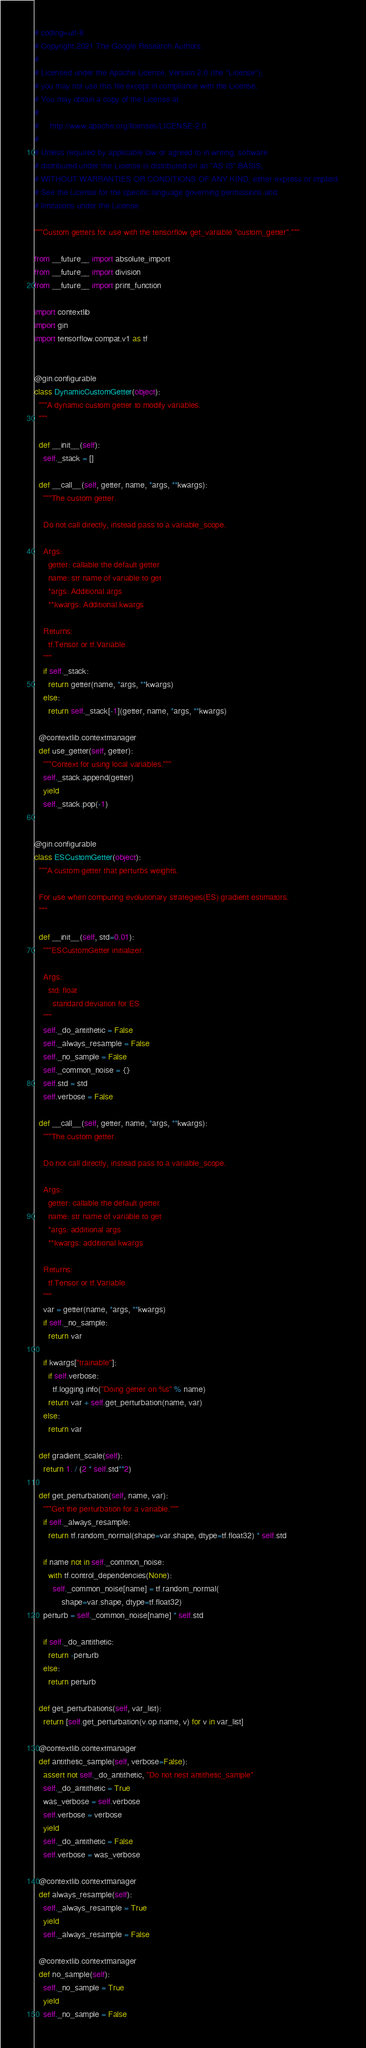<code> <loc_0><loc_0><loc_500><loc_500><_Python_># coding=utf-8
# Copyright 2021 The Google Research Authors.
#
# Licensed under the Apache License, Version 2.0 (the "License");
# you may not use this file except in compliance with the License.
# You may obtain a copy of the License at
#
#     http://www.apache.org/licenses/LICENSE-2.0
#
# Unless required by applicable law or agreed to in writing, software
# distributed under the License is distributed on an "AS IS" BASIS,
# WITHOUT WARRANTIES OR CONDITIONS OF ANY KIND, either express or implied.
# See the License for the specific language governing permissions and
# limitations under the License.

"""Custom getters for use with the tensorflow get_variable "custom_getter"."""

from __future__ import absolute_import
from __future__ import division
from __future__ import print_function

import contextlib
import gin
import tensorflow.compat.v1 as tf


@gin.configurable
class DynamicCustomGetter(object):
  """A dynamic custom getter to modify variables.
  """

  def __init__(self):
    self._stack = []

  def __call__(self, getter, name, *args, **kwargs):
    """The custom getter.

    Do not call directly, instead pass to a variable_scope.

    Args:
      getter: callable the default getter
      name: str name of variable to get
      *args: Additional args
      **kwargs: Additional kwargs

    Returns:
      tf.Tensor or tf.Variable
    """
    if self._stack:
      return getter(name, *args, **kwargs)
    else:
      return self._stack[-1](getter, name, *args, **kwargs)

  @contextlib.contextmanager
  def use_getter(self, getter):
    """Context for using local variables."""
    self._stack.append(getter)
    yield
    self._stack.pop(-1)


@gin.configurable
class ESCustomGetter(object):
  """A custom getter that perturbs weights.

  For use when computing evolutionary strategies(ES) gradient estimators.
  """

  def __init__(self, std=0.01):
    """ESCustomGetter initializer.

    Args:
      std: float
        standard deviation for ES
    """
    self._do_antithetic = False
    self._always_resample = False
    self._no_sample = False
    self._common_noise = {}
    self.std = std
    self.verbose = False

  def __call__(self, getter, name, *args, **kwargs):
    """The custom getter.

    Do not call directly, instead pass to a variable_scope.

    Args:
      getter: callable the default getter
      name: str name of variable to get
      *args: additional args
      **kwargs: additional kwargs

    Returns:
      tf.Tensor or tf.Variable
    """
    var = getter(name, *args, **kwargs)
    if self._no_sample:
      return var

    if kwargs["trainable"]:
      if self.verbose:
        tf.logging.info("Doing getter on %s" % name)
      return var + self.get_perturbation(name, var)
    else:
      return var

  def gradient_scale(self):
    return 1. / (2 * self.std**2)

  def get_perturbation(self, name, var):
    """Get the perturbation for a variable."""
    if self._always_resample:
      return tf.random_normal(shape=var.shape, dtype=tf.float32) * self.std

    if name not in self._common_noise:
      with tf.control_dependencies(None):
        self._common_noise[name] = tf.random_normal(
            shape=var.shape, dtype=tf.float32)
    perturb = self._common_noise[name] * self.std

    if self._do_antithetic:
      return -perturb
    else:
      return perturb

  def get_perturbations(self, var_list):
    return [self.get_perturbation(v.op.name, v) for v in var_list]

  @contextlib.contextmanager
  def antithetic_sample(self, verbose=False):
    assert not self._do_antithetic, "Do not nest antithetic_sample"
    self._do_antithetic = True
    was_verbose = self.verbose
    self.verbose = verbose
    yield
    self._do_antithetic = False
    self.verbose = was_verbose

  @contextlib.contextmanager
  def always_resample(self):
    self._always_resample = True
    yield
    self._always_resample = False

  @contextlib.contextmanager
  def no_sample(self):
    self._no_sample = True
    yield
    self._no_sample = False
</code> 